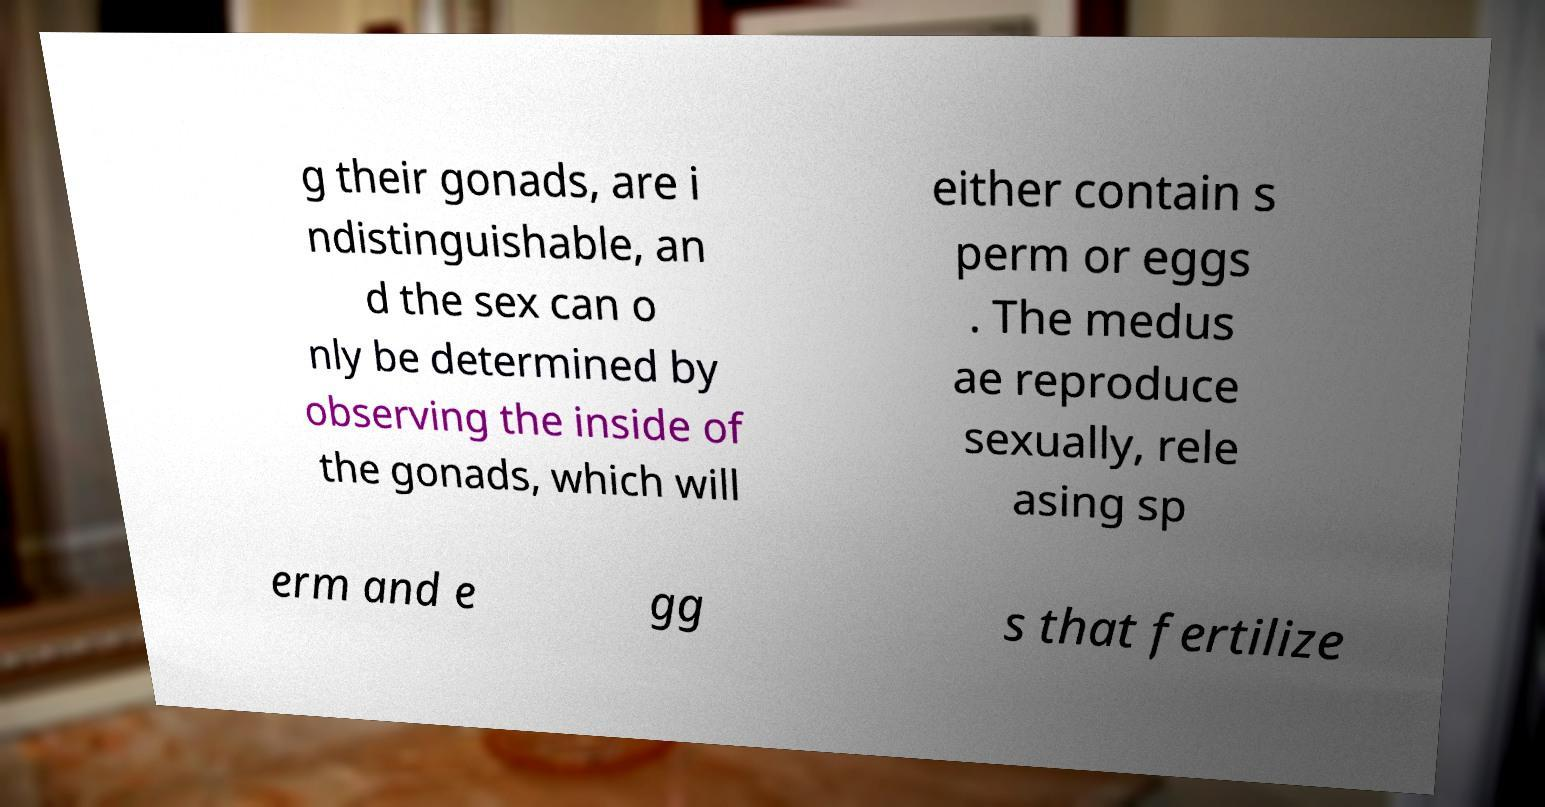Can you read and provide the text displayed in the image?This photo seems to have some interesting text. Can you extract and type it out for me? g their gonads, are i ndistinguishable, an d the sex can o nly be determined by observing the inside of the gonads, which will either contain s perm or eggs . The medus ae reproduce sexually, rele asing sp erm and e gg s that fertilize 